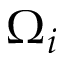Convert formula to latex. <formula><loc_0><loc_0><loc_500><loc_500>\Omega _ { i }</formula> 